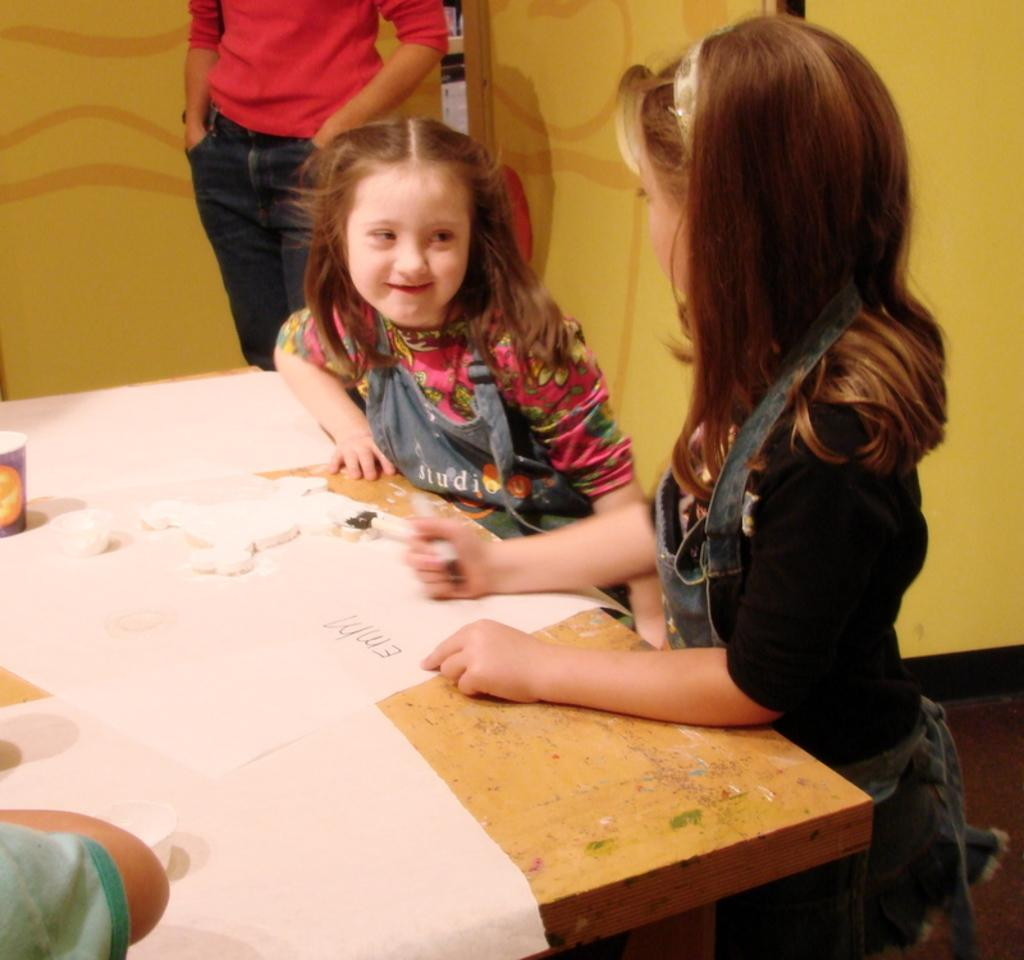How many girls are in the image? There are two small girls standing in the image. What is on the table in the image? There is a table with papers on it. Are there any other people besides the girls in the image? Yes, there is another person standing in the image. Can you describe the hand visible in the image? A person's hand is visible in the bottom left corner of the image. What type of knowledge can be gained from the store in the image? There is no store present in the image, so no knowledge can be gained from it. 